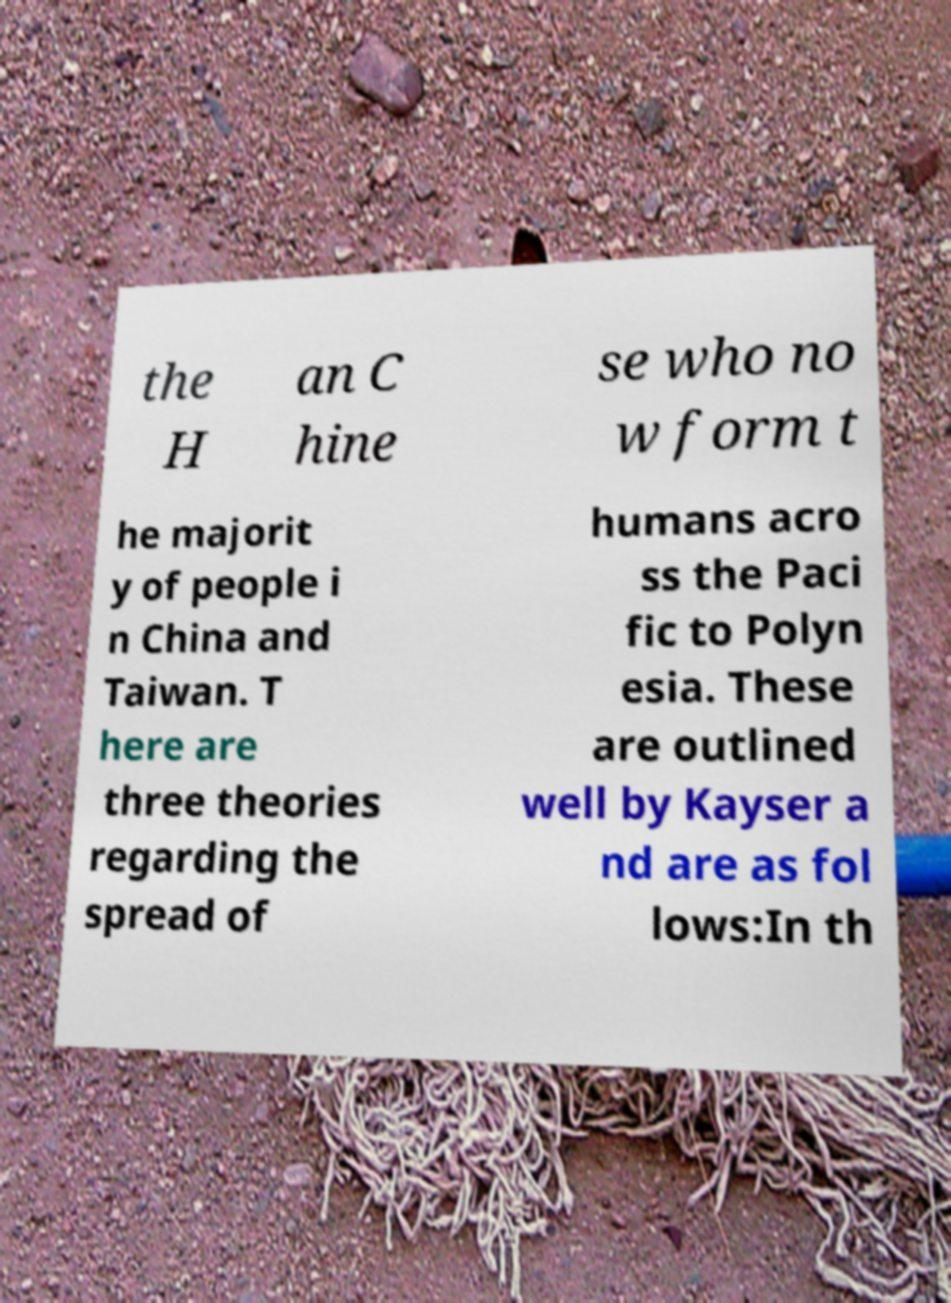Could you assist in decoding the text presented in this image and type it out clearly? the H an C hine se who no w form t he majorit y of people i n China and Taiwan. T here are three theories regarding the spread of humans acro ss the Paci fic to Polyn esia. These are outlined well by Kayser a nd are as fol lows:In th 